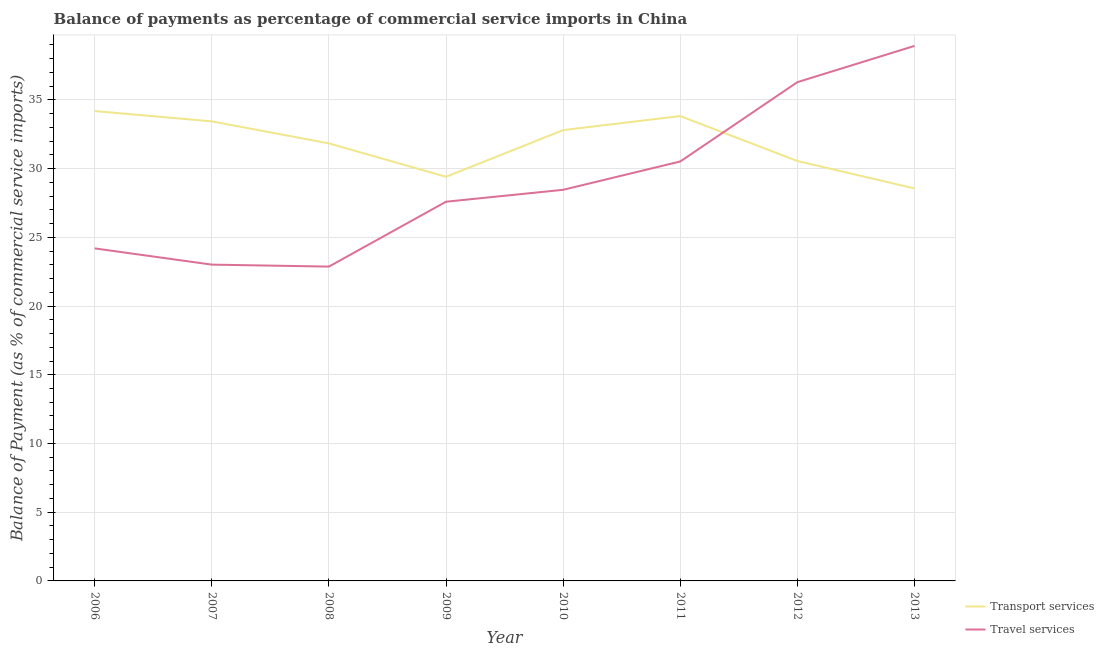How many different coloured lines are there?
Your answer should be very brief. 2. Is the number of lines equal to the number of legend labels?
Your answer should be compact. Yes. What is the balance of payments of transport services in 2008?
Offer a terse response. 31.83. Across all years, what is the maximum balance of payments of transport services?
Your response must be concise. 34.19. Across all years, what is the minimum balance of payments of travel services?
Provide a succinct answer. 22.87. In which year was the balance of payments of travel services minimum?
Offer a very short reply. 2008. What is the total balance of payments of travel services in the graph?
Provide a succinct answer. 231.86. What is the difference between the balance of payments of transport services in 2006 and that in 2008?
Provide a short and direct response. 2.35. What is the difference between the balance of payments of transport services in 2010 and the balance of payments of travel services in 2011?
Your answer should be very brief. 2.28. What is the average balance of payments of transport services per year?
Provide a succinct answer. 31.82. In the year 2013, what is the difference between the balance of payments of transport services and balance of payments of travel services?
Offer a very short reply. -10.37. What is the ratio of the balance of payments of travel services in 2007 to that in 2012?
Keep it short and to the point. 0.63. Is the difference between the balance of payments of travel services in 2010 and 2013 greater than the difference between the balance of payments of transport services in 2010 and 2013?
Offer a terse response. No. What is the difference between the highest and the second highest balance of payments of transport services?
Offer a terse response. 0.37. What is the difference between the highest and the lowest balance of payments of travel services?
Make the answer very short. 16.06. In how many years, is the balance of payments of transport services greater than the average balance of payments of transport services taken over all years?
Your response must be concise. 5. Is the sum of the balance of payments of travel services in 2006 and 2009 greater than the maximum balance of payments of transport services across all years?
Make the answer very short. Yes. Does the balance of payments of transport services monotonically increase over the years?
Offer a very short reply. No. Is the balance of payments of transport services strictly greater than the balance of payments of travel services over the years?
Keep it short and to the point. No. Is the balance of payments of travel services strictly less than the balance of payments of transport services over the years?
Your answer should be compact. No. How many lines are there?
Keep it short and to the point. 2. Are the values on the major ticks of Y-axis written in scientific E-notation?
Provide a succinct answer. No. Does the graph contain any zero values?
Provide a short and direct response. No. How many legend labels are there?
Your response must be concise. 2. How are the legend labels stacked?
Your answer should be very brief. Vertical. What is the title of the graph?
Keep it short and to the point. Balance of payments as percentage of commercial service imports in China. What is the label or title of the X-axis?
Provide a succinct answer. Year. What is the label or title of the Y-axis?
Keep it short and to the point. Balance of Payment (as % of commercial service imports). What is the Balance of Payment (as % of commercial service imports) of Transport services in 2006?
Offer a terse response. 34.19. What is the Balance of Payment (as % of commercial service imports) in Travel services in 2006?
Your response must be concise. 24.19. What is the Balance of Payment (as % of commercial service imports) of Transport services in 2007?
Give a very brief answer. 33.44. What is the Balance of Payment (as % of commercial service imports) of Travel services in 2007?
Keep it short and to the point. 23.01. What is the Balance of Payment (as % of commercial service imports) in Transport services in 2008?
Offer a very short reply. 31.83. What is the Balance of Payment (as % of commercial service imports) in Travel services in 2008?
Provide a succinct answer. 22.87. What is the Balance of Payment (as % of commercial service imports) of Transport services in 2009?
Make the answer very short. 29.4. What is the Balance of Payment (as % of commercial service imports) of Travel services in 2009?
Your response must be concise. 27.59. What is the Balance of Payment (as % of commercial service imports) of Transport services in 2010?
Provide a succinct answer. 32.8. What is the Balance of Payment (as % of commercial service imports) in Travel services in 2010?
Ensure brevity in your answer.  28.46. What is the Balance of Payment (as % of commercial service imports) in Transport services in 2011?
Your answer should be very brief. 33.82. What is the Balance of Payment (as % of commercial service imports) of Travel services in 2011?
Offer a terse response. 30.52. What is the Balance of Payment (as % of commercial service imports) of Transport services in 2012?
Provide a succinct answer. 30.55. What is the Balance of Payment (as % of commercial service imports) in Travel services in 2012?
Give a very brief answer. 36.29. What is the Balance of Payment (as % of commercial service imports) in Transport services in 2013?
Ensure brevity in your answer.  28.56. What is the Balance of Payment (as % of commercial service imports) in Travel services in 2013?
Make the answer very short. 38.93. Across all years, what is the maximum Balance of Payment (as % of commercial service imports) of Transport services?
Your answer should be compact. 34.19. Across all years, what is the maximum Balance of Payment (as % of commercial service imports) in Travel services?
Your answer should be compact. 38.93. Across all years, what is the minimum Balance of Payment (as % of commercial service imports) in Transport services?
Offer a very short reply. 28.56. Across all years, what is the minimum Balance of Payment (as % of commercial service imports) of Travel services?
Ensure brevity in your answer.  22.87. What is the total Balance of Payment (as % of commercial service imports) in Transport services in the graph?
Offer a very short reply. 254.59. What is the total Balance of Payment (as % of commercial service imports) of Travel services in the graph?
Give a very brief answer. 231.86. What is the difference between the Balance of Payment (as % of commercial service imports) in Transport services in 2006 and that in 2007?
Offer a terse response. 0.75. What is the difference between the Balance of Payment (as % of commercial service imports) in Travel services in 2006 and that in 2007?
Your answer should be very brief. 1.18. What is the difference between the Balance of Payment (as % of commercial service imports) of Transport services in 2006 and that in 2008?
Your response must be concise. 2.35. What is the difference between the Balance of Payment (as % of commercial service imports) of Travel services in 2006 and that in 2008?
Offer a terse response. 1.32. What is the difference between the Balance of Payment (as % of commercial service imports) in Transport services in 2006 and that in 2009?
Provide a short and direct response. 4.78. What is the difference between the Balance of Payment (as % of commercial service imports) in Travel services in 2006 and that in 2009?
Provide a short and direct response. -3.4. What is the difference between the Balance of Payment (as % of commercial service imports) in Transport services in 2006 and that in 2010?
Make the answer very short. 1.39. What is the difference between the Balance of Payment (as % of commercial service imports) of Travel services in 2006 and that in 2010?
Provide a succinct answer. -4.26. What is the difference between the Balance of Payment (as % of commercial service imports) in Transport services in 2006 and that in 2011?
Ensure brevity in your answer.  0.37. What is the difference between the Balance of Payment (as % of commercial service imports) of Travel services in 2006 and that in 2011?
Your answer should be compact. -6.32. What is the difference between the Balance of Payment (as % of commercial service imports) of Transport services in 2006 and that in 2012?
Offer a very short reply. 3.63. What is the difference between the Balance of Payment (as % of commercial service imports) in Travel services in 2006 and that in 2012?
Your answer should be compact. -12.1. What is the difference between the Balance of Payment (as % of commercial service imports) in Transport services in 2006 and that in 2013?
Your response must be concise. 5.63. What is the difference between the Balance of Payment (as % of commercial service imports) of Travel services in 2006 and that in 2013?
Make the answer very short. -14.73. What is the difference between the Balance of Payment (as % of commercial service imports) in Transport services in 2007 and that in 2008?
Give a very brief answer. 1.6. What is the difference between the Balance of Payment (as % of commercial service imports) in Travel services in 2007 and that in 2008?
Your answer should be very brief. 0.14. What is the difference between the Balance of Payment (as % of commercial service imports) in Transport services in 2007 and that in 2009?
Your response must be concise. 4.03. What is the difference between the Balance of Payment (as % of commercial service imports) in Travel services in 2007 and that in 2009?
Give a very brief answer. -4.58. What is the difference between the Balance of Payment (as % of commercial service imports) of Transport services in 2007 and that in 2010?
Make the answer very short. 0.64. What is the difference between the Balance of Payment (as % of commercial service imports) in Travel services in 2007 and that in 2010?
Your answer should be very brief. -5.44. What is the difference between the Balance of Payment (as % of commercial service imports) of Transport services in 2007 and that in 2011?
Your answer should be very brief. -0.39. What is the difference between the Balance of Payment (as % of commercial service imports) in Travel services in 2007 and that in 2011?
Your answer should be compact. -7.5. What is the difference between the Balance of Payment (as % of commercial service imports) of Transport services in 2007 and that in 2012?
Your answer should be compact. 2.88. What is the difference between the Balance of Payment (as % of commercial service imports) of Travel services in 2007 and that in 2012?
Make the answer very short. -13.28. What is the difference between the Balance of Payment (as % of commercial service imports) in Transport services in 2007 and that in 2013?
Provide a succinct answer. 4.88. What is the difference between the Balance of Payment (as % of commercial service imports) in Travel services in 2007 and that in 2013?
Ensure brevity in your answer.  -15.91. What is the difference between the Balance of Payment (as % of commercial service imports) in Transport services in 2008 and that in 2009?
Ensure brevity in your answer.  2.43. What is the difference between the Balance of Payment (as % of commercial service imports) in Travel services in 2008 and that in 2009?
Offer a very short reply. -4.72. What is the difference between the Balance of Payment (as % of commercial service imports) of Transport services in 2008 and that in 2010?
Keep it short and to the point. -0.97. What is the difference between the Balance of Payment (as % of commercial service imports) in Travel services in 2008 and that in 2010?
Ensure brevity in your answer.  -5.59. What is the difference between the Balance of Payment (as % of commercial service imports) in Transport services in 2008 and that in 2011?
Your answer should be compact. -1.99. What is the difference between the Balance of Payment (as % of commercial service imports) in Travel services in 2008 and that in 2011?
Your response must be concise. -7.65. What is the difference between the Balance of Payment (as % of commercial service imports) of Transport services in 2008 and that in 2012?
Give a very brief answer. 1.28. What is the difference between the Balance of Payment (as % of commercial service imports) in Travel services in 2008 and that in 2012?
Make the answer very short. -13.42. What is the difference between the Balance of Payment (as % of commercial service imports) of Transport services in 2008 and that in 2013?
Provide a succinct answer. 3.28. What is the difference between the Balance of Payment (as % of commercial service imports) of Travel services in 2008 and that in 2013?
Keep it short and to the point. -16.06. What is the difference between the Balance of Payment (as % of commercial service imports) of Transport services in 2009 and that in 2010?
Provide a succinct answer. -3.4. What is the difference between the Balance of Payment (as % of commercial service imports) of Travel services in 2009 and that in 2010?
Your response must be concise. -0.87. What is the difference between the Balance of Payment (as % of commercial service imports) of Transport services in 2009 and that in 2011?
Your answer should be compact. -4.42. What is the difference between the Balance of Payment (as % of commercial service imports) of Travel services in 2009 and that in 2011?
Your response must be concise. -2.93. What is the difference between the Balance of Payment (as % of commercial service imports) in Transport services in 2009 and that in 2012?
Your answer should be very brief. -1.15. What is the difference between the Balance of Payment (as % of commercial service imports) in Travel services in 2009 and that in 2012?
Your answer should be compact. -8.7. What is the difference between the Balance of Payment (as % of commercial service imports) of Transport services in 2009 and that in 2013?
Keep it short and to the point. 0.85. What is the difference between the Balance of Payment (as % of commercial service imports) in Travel services in 2009 and that in 2013?
Make the answer very short. -11.34. What is the difference between the Balance of Payment (as % of commercial service imports) in Transport services in 2010 and that in 2011?
Offer a terse response. -1.02. What is the difference between the Balance of Payment (as % of commercial service imports) of Travel services in 2010 and that in 2011?
Provide a short and direct response. -2.06. What is the difference between the Balance of Payment (as % of commercial service imports) of Transport services in 2010 and that in 2012?
Make the answer very short. 2.25. What is the difference between the Balance of Payment (as % of commercial service imports) of Travel services in 2010 and that in 2012?
Your answer should be compact. -7.83. What is the difference between the Balance of Payment (as % of commercial service imports) of Transport services in 2010 and that in 2013?
Your answer should be compact. 4.24. What is the difference between the Balance of Payment (as % of commercial service imports) in Travel services in 2010 and that in 2013?
Give a very brief answer. -10.47. What is the difference between the Balance of Payment (as % of commercial service imports) in Transport services in 2011 and that in 2012?
Ensure brevity in your answer.  3.27. What is the difference between the Balance of Payment (as % of commercial service imports) of Travel services in 2011 and that in 2012?
Your response must be concise. -5.77. What is the difference between the Balance of Payment (as % of commercial service imports) in Transport services in 2011 and that in 2013?
Offer a terse response. 5.27. What is the difference between the Balance of Payment (as % of commercial service imports) in Travel services in 2011 and that in 2013?
Ensure brevity in your answer.  -8.41. What is the difference between the Balance of Payment (as % of commercial service imports) of Transport services in 2012 and that in 2013?
Your answer should be very brief. 2. What is the difference between the Balance of Payment (as % of commercial service imports) of Travel services in 2012 and that in 2013?
Offer a terse response. -2.64. What is the difference between the Balance of Payment (as % of commercial service imports) of Transport services in 2006 and the Balance of Payment (as % of commercial service imports) of Travel services in 2007?
Provide a succinct answer. 11.17. What is the difference between the Balance of Payment (as % of commercial service imports) in Transport services in 2006 and the Balance of Payment (as % of commercial service imports) in Travel services in 2008?
Offer a terse response. 11.32. What is the difference between the Balance of Payment (as % of commercial service imports) in Transport services in 2006 and the Balance of Payment (as % of commercial service imports) in Travel services in 2009?
Offer a terse response. 6.6. What is the difference between the Balance of Payment (as % of commercial service imports) in Transport services in 2006 and the Balance of Payment (as % of commercial service imports) in Travel services in 2010?
Provide a succinct answer. 5.73. What is the difference between the Balance of Payment (as % of commercial service imports) of Transport services in 2006 and the Balance of Payment (as % of commercial service imports) of Travel services in 2011?
Offer a very short reply. 3.67. What is the difference between the Balance of Payment (as % of commercial service imports) of Transport services in 2006 and the Balance of Payment (as % of commercial service imports) of Travel services in 2012?
Provide a short and direct response. -2.1. What is the difference between the Balance of Payment (as % of commercial service imports) of Transport services in 2006 and the Balance of Payment (as % of commercial service imports) of Travel services in 2013?
Your response must be concise. -4.74. What is the difference between the Balance of Payment (as % of commercial service imports) of Transport services in 2007 and the Balance of Payment (as % of commercial service imports) of Travel services in 2008?
Keep it short and to the point. 10.57. What is the difference between the Balance of Payment (as % of commercial service imports) of Transport services in 2007 and the Balance of Payment (as % of commercial service imports) of Travel services in 2009?
Make the answer very short. 5.84. What is the difference between the Balance of Payment (as % of commercial service imports) of Transport services in 2007 and the Balance of Payment (as % of commercial service imports) of Travel services in 2010?
Keep it short and to the point. 4.98. What is the difference between the Balance of Payment (as % of commercial service imports) in Transport services in 2007 and the Balance of Payment (as % of commercial service imports) in Travel services in 2011?
Your response must be concise. 2.92. What is the difference between the Balance of Payment (as % of commercial service imports) in Transport services in 2007 and the Balance of Payment (as % of commercial service imports) in Travel services in 2012?
Your response must be concise. -2.85. What is the difference between the Balance of Payment (as % of commercial service imports) of Transport services in 2007 and the Balance of Payment (as % of commercial service imports) of Travel services in 2013?
Provide a succinct answer. -5.49. What is the difference between the Balance of Payment (as % of commercial service imports) of Transport services in 2008 and the Balance of Payment (as % of commercial service imports) of Travel services in 2009?
Offer a very short reply. 4.24. What is the difference between the Balance of Payment (as % of commercial service imports) in Transport services in 2008 and the Balance of Payment (as % of commercial service imports) in Travel services in 2010?
Offer a terse response. 3.38. What is the difference between the Balance of Payment (as % of commercial service imports) in Transport services in 2008 and the Balance of Payment (as % of commercial service imports) in Travel services in 2011?
Keep it short and to the point. 1.32. What is the difference between the Balance of Payment (as % of commercial service imports) in Transport services in 2008 and the Balance of Payment (as % of commercial service imports) in Travel services in 2012?
Keep it short and to the point. -4.45. What is the difference between the Balance of Payment (as % of commercial service imports) in Transport services in 2008 and the Balance of Payment (as % of commercial service imports) in Travel services in 2013?
Make the answer very short. -7.09. What is the difference between the Balance of Payment (as % of commercial service imports) of Transport services in 2009 and the Balance of Payment (as % of commercial service imports) of Travel services in 2010?
Your response must be concise. 0.95. What is the difference between the Balance of Payment (as % of commercial service imports) of Transport services in 2009 and the Balance of Payment (as % of commercial service imports) of Travel services in 2011?
Your response must be concise. -1.11. What is the difference between the Balance of Payment (as % of commercial service imports) of Transport services in 2009 and the Balance of Payment (as % of commercial service imports) of Travel services in 2012?
Your answer should be very brief. -6.88. What is the difference between the Balance of Payment (as % of commercial service imports) of Transport services in 2009 and the Balance of Payment (as % of commercial service imports) of Travel services in 2013?
Provide a short and direct response. -9.52. What is the difference between the Balance of Payment (as % of commercial service imports) of Transport services in 2010 and the Balance of Payment (as % of commercial service imports) of Travel services in 2011?
Offer a very short reply. 2.28. What is the difference between the Balance of Payment (as % of commercial service imports) in Transport services in 2010 and the Balance of Payment (as % of commercial service imports) in Travel services in 2012?
Provide a succinct answer. -3.49. What is the difference between the Balance of Payment (as % of commercial service imports) in Transport services in 2010 and the Balance of Payment (as % of commercial service imports) in Travel services in 2013?
Keep it short and to the point. -6.13. What is the difference between the Balance of Payment (as % of commercial service imports) of Transport services in 2011 and the Balance of Payment (as % of commercial service imports) of Travel services in 2012?
Your answer should be compact. -2.47. What is the difference between the Balance of Payment (as % of commercial service imports) of Transport services in 2011 and the Balance of Payment (as % of commercial service imports) of Travel services in 2013?
Keep it short and to the point. -5.1. What is the difference between the Balance of Payment (as % of commercial service imports) of Transport services in 2012 and the Balance of Payment (as % of commercial service imports) of Travel services in 2013?
Make the answer very short. -8.37. What is the average Balance of Payment (as % of commercial service imports) of Transport services per year?
Your answer should be compact. 31.82. What is the average Balance of Payment (as % of commercial service imports) in Travel services per year?
Your response must be concise. 28.98. In the year 2006, what is the difference between the Balance of Payment (as % of commercial service imports) in Transport services and Balance of Payment (as % of commercial service imports) in Travel services?
Keep it short and to the point. 9.99. In the year 2007, what is the difference between the Balance of Payment (as % of commercial service imports) in Transport services and Balance of Payment (as % of commercial service imports) in Travel services?
Your answer should be very brief. 10.42. In the year 2008, what is the difference between the Balance of Payment (as % of commercial service imports) in Transport services and Balance of Payment (as % of commercial service imports) in Travel services?
Make the answer very short. 8.96. In the year 2009, what is the difference between the Balance of Payment (as % of commercial service imports) in Transport services and Balance of Payment (as % of commercial service imports) in Travel services?
Provide a short and direct response. 1.81. In the year 2010, what is the difference between the Balance of Payment (as % of commercial service imports) in Transport services and Balance of Payment (as % of commercial service imports) in Travel services?
Provide a short and direct response. 4.34. In the year 2011, what is the difference between the Balance of Payment (as % of commercial service imports) of Transport services and Balance of Payment (as % of commercial service imports) of Travel services?
Ensure brevity in your answer.  3.3. In the year 2012, what is the difference between the Balance of Payment (as % of commercial service imports) in Transport services and Balance of Payment (as % of commercial service imports) in Travel services?
Offer a terse response. -5.73. In the year 2013, what is the difference between the Balance of Payment (as % of commercial service imports) in Transport services and Balance of Payment (as % of commercial service imports) in Travel services?
Make the answer very short. -10.37. What is the ratio of the Balance of Payment (as % of commercial service imports) in Transport services in 2006 to that in 2007?
Your response must be concise. 1.02. What is the ratio of the Balance of Payment (as % of commercial service imports) in Travel services in 2006 to that in 2007?
Provide a succinct answer. 1.05. What is the ratio of the Balance of Payment (as % of commercial service imports) of Transport services in 2006 to that in 2008?
Your answer should be compact. 1.07. What is the ratio of the Balance of Payment (as % of commercial service imports) in Travel services in 2006 to that in 2008?
Your response must be concise. 1.06. What is the ratio of the Balance of Payment (as % of commercial service imports) in Transport services in 2006 to that in 2009?
Ensure brevity in your answer.  1.16. What is the ratio of the Balance of Payment (as % of commercial service imports) in Travel services in 2006 to that in 2009?
Give a very brief answer. 0.88. What is the ratio of the Balance of Payment (as % of commercial service imports) of Transport services in 2006 to that in 2010?
Keep it short and to the point. 1.04. What is the ratio of the Balance of Payment (as % of commercial service imports) of Travel services in 2006 to that in 2010?
Your response must be concise. 0.85. What is the ratio of the Balance of Payment (as % of commercial service imports) in Transport services in 2006 to that in 2011?
Ensure brevity in your answer.  1.01. What is the ratio of the Balance of Payment (as % of commercial service imports) of Travel services in 2006 to that in 2011?
Your answer should be very brief. 0.79. What is the ratio of the Balance of Payment (as % of commercial service imports) in Transport services in 2006 to that in 2012?
Make the answer very short. 1.12. What is the ratio of the Balance of Payment (as % of commercial service imports) in Travel services in 2006 to that in 2012?
Offer a terse response. 0.67. What is the ratio of the Balance of Payment (as % of commercial service imports) in Transport services in 2006 to that in 2013?
Give a very brief answer. 1.2. What is the ratio of the Balance of Payment (as % of commercial service imports) in Travel services in 2006 to that in 2013?
Provide a short and direct response. 0.62. What is the ratio of the Balance of Payment (as % of commercial service imports) of Transport services in 2007 to that in 2008?
Provide a short and direct response. 1.05. What is the ratio of the Balance of Payment (as % of commercial service imports) in Travel services in 2007 to that in 2008?
Provide a short and direct response. 1.01. What is the ratio of the Balance of Payment (as % of commercial service imports) of Transport services in 2007 to that in 2009?
Ensure brevity in your answer.  1.14. What is the ratio of the Balance of Payment (as % of commercial service imports) in Travel services in 2007 to that in 2009?
Your answer should be very brief. 0.83. What is the ratio of the Balance of Payment (as % of commercial service imports) of Transport services in 2007 to that in 2010?
Give a very brief answer. 1.02. What is the ratio of the Balance of Payment (as % of commercial service imports) in Travel services in 2007 to that in 2010?
Provide a short and direct response. 0.81. What is the ratio of the Balance of Payment (as % of commercial service imports) in Travel services in 2007 to that in 2011?
Make the answer very short. 0.75. What is the ratio of the Balance of Payment (as % of commercial service imports) of Transport services in 2007 to that in 2012?
Make the answer very short. 1.09. What is the ratio of the Balance of Payment (as % of commercial service imports) in Travel services in 2007 to that in 2012?
Your answer should be very brief. 0.63. What is the ratio of the Balance of Payment (as % of commercial service imports) in Transport services in 2007 to that in 2013?
Your answer should be compact. 1.17. What is the ratio of the Balance of Payment (as % of commercial service imports) of Travel services in 2007 to that in 2013?
Your answer should be very brief. 0.59. What is the ratio of the Balance of Payment (as % of commercial service imports) in Transport services in 2008 to that in 2009?
Offer a very short reply. 1.08. What is the ratio of the Balance of Payment (as % of commercial service imports) of Travel services in 2008 to that in 2009?
Your answer should be very brief. 0.83. What is the ratio of the Balance of Payment (as % of commercial service imports) of Transport services in 2008 to that in 2010?
Your answer should be very brief. 0.97. What is the ratio of the Balance of Payment (as % of commercial service imports) in Travel services in 2008 to that in 2010?
Your answer should be very brief. 0.8. What is the ratio of the Balance of Payment (as % of commercial service imports) in Transport services in 2008 to that in 2011?
Your answer should be compact. 0.94. What is the ratio of the Balance of Payment (as % of commercial service imports) of Travel services in 2008 to that in 2011?
Offer a terse response. 0.75. What is the ratio of the Balance of Payment (as % of commercial service imports) of Transport services in 2008 to that in 2012?
Your response must be concise. 1.04. What is the ratio of the Balance of Payment (as % of commercial service imports) in Travel services in 2008 to that in 2012?
Offer a very short reply. 0.63. What is the ratio of the Balance of Payment (as % of commercial service imports) of Transport services in 2008 to that in 2013?
Your answer should be compact. 1.11. What is the ratio of the Balance of Payment (as % of commercial service imports) of Travel services in 2008 to that in 2013?
Ensure brevity in your answer.  0.59. What is the ratio of the Balance of Payment (as % of commercial service imports) of Transport services in 2009 to that in 2010?
Offer a very short reply. 0.9. What is the ratio of the Balance of Payment (as % of commercial service imports) in Travel services in 2009 to that in 2010?
Make the answer very short. 0.97. What is the ratio of the Balance of Payment (as % of commercial service imports) in Transport services in 2009 to that in 2011?
Make the answer very short. 0.87. What is the ratio of the Balance of Payment (as % of commercial service imports) in Travel services in 2009 to that in 2011?
Your answer should be compact. 0.9. What is the ratio of the Balance of Payment (as % of commercial service imports) in Transport services in 2009 to that in 2012?
Make the answer very short. 0.96. What is the ratio of the Balance of Payment (as % of commercial service imports) of Travel services in 2009 to that in 2012?
Make the answer very short. 0.76. What is the ratio of the Balance of Payment (as % of commercial service imports) of Transport services in 2009 to that in 2013?
Keep it short and to the point. 1.03. What is the ratio of the Balance of Payment (as % of commercial service imports) of Travel services in 2009 to that in 2013?
Give a very brief answer. 0.71. What is the ratio of the Balance of Payment (as % of commercial service imports) in Transport services in 2010 to that in 2011?
Make the answer very short. 0.97. What is the ratio of the Balance of Payment (as % of commercial service imports) of Travel services in 2010 to that in 2011?
Keep it short and to the point. 0.93. What is the ratio of the Balance of Payment (as % of commercial service imports) in Transport services in 2010 to that in 2012?
Provide a short and direct response. 1.07. What is the ratio of the Balance of Payment (as % of commercial service imports) in Travel services in 2010 to that in 2012?
Provide a succinct answer. 0.78. What is the ratio of the Balance of Payment (as % of commercial service imports) in Transport services in 2010 to that in 2013?
Your answer should be very brief. 1.15. What is the ratio of the Balance of Payment (as % of commercial service imports) in Travel services in 2010 to that in 2013?
Your answer should be very brief. 0.73. What is the ratio of the Balance of Payment (as % of commercial service imports) in Transport services in 2011 to that in 2012?
Your answer should be compact. 1.11. What is the ratio of the Balance of Payment (as % of commercial service imports) in Travel services in 2011 to that in 2012?
Make the answer very short. 0.84. What is the ratio of the Balance of Payment (as % of commercial service imports) of Transport services in 2011 to that in 2013?
Provide a succinct answer. 1.18. What is the ratio of the Balance of Payment (as % of commercial service imports) in Travel services in 2011 to that in 2013?
Make the answer very short. 0.78. What is the ratio of the Balance of Payment (as % of commercial service imports) of Transport services in 2012 to that in 2013?
Your response must be concise. 1.07. What is the ratio of the Balance of Payment (as % of commercial service imports) in Travel services in 2012 to that in 2013?
Ensure brevity in your answer.  0.93. What is the difference between the highest and the second highest Balance of Payment (as % of commercial service imports) in Transport services?
Offer a very short reply. 0.37. What is the difference between the highest and the second highest Balance of Payment (as % of commercial service imports) in Travel services?
Your answer should be very brief. 2.64. What is the difference between the highest and the lowest Balance of Payment (as % of commercial service imports) in Transport services?
Provide a succinct answer. 5.63. What is the difference between the highest and the lowest Balance of Payment (as % of commercial service imports) in Travel services?
Your answer should be very brief. 16.06. 